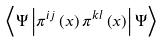<formula> <loc_0><loc_0><loc_500><loc_500>\left \langle \Psi \left | \pi ^ { i j } \left ( x \right ) \pi ^ { k l } \left ( x \right ) \right | \Psi \right \rangle</formula> 